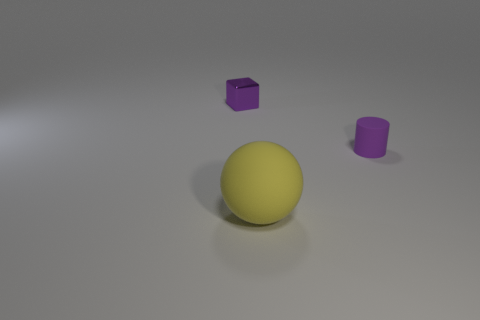Is there any other thing that has the same size as the matte sphere?
Give a very brief answer. No. How many tiny objects are either purple objects or rubber spheres?
Provide a short and direct response. 2. What shape is the purple object that is made of the same material as the large ball?
Keep it short and to the point. Cylinder. What is the color of the tiny shiny object?
Keep it short and to the point. Purple. What number of things are either rubber cylinders or large yellow balls?
Make the answer very short. 2. Are there any other things that have the same material as the tiny cube?
Offer a very short reply. No. Are there fewer large yellow things that are to the left of the yellow ball than tiny red balls?
Your answer should be very brief. No. Are there more big yellow objects in front of the small purple shiny object than purple cylinders that are on the right side of the rubber cylinder?
Provide a succinct answer. Yes. Is there anything else that is the same color as the metallic cube?
Keep it short and to the point. Yes. What material is the thing to the right of the yellow rubber object?
Your response must be concise. Rubber. 